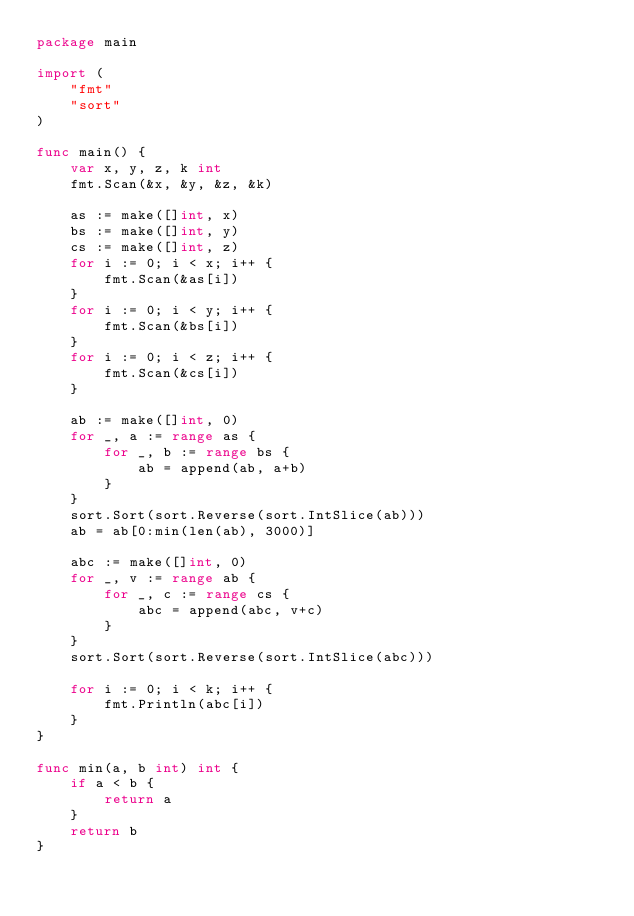<code> <loc_0><loc_0><loc_500><loc_500><_Go_>package main

import (
	"fmt"
	"sort"
)

func main() {
	var x, y, z, k int
	fmt.Scan(&x, &y, &z, &k)

	as := make([]int, x)
	bs := make([]int, y)
	cs := make([]int, z)
	for i := 0; i < x; i++ {
		fmt.Scan(&as[i])
	}
	for i := 0; i < y; i++ {
		fmt.Scan(&bs[i])
	}
	for i := 0; i < z; i++ {
		fmt.Scan(&cs[i])
	}

	ab := make([]int, 0)
	for _, a := range as {
		for _, b := range bs {
			ab = append(ab, a+b)
		}
	}
	sort.Sort(sort.Reverse(sort.IntSlice(ab)))
	ab = ab[0:min(len(ab), 3000)]

	abc := make([]int, 0)
	for _, v := range ab {
		for _, c := range cs {
			abc = append(abc, v+c)
		}
	}
	sort.Sort(sort.Reverse(sort.IntSlice(abc)))

	for i := 0; i < k; i++ {
		fmt.Println(abc[i])
	}
}

func min(a, b int) int {
	if a < b {
		return a
	}
	return b
}
</code> 